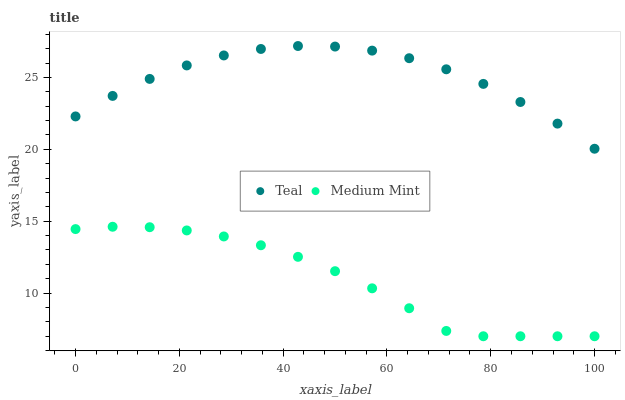Does Medium Mint have the minimum area under the curve?
Answer yes or no. Yes. Does Teal have the maximum area under the curve?
Answer yes or no. Yes. Does Teal have the minimum area under the curve?
Answer yes or no. No. Is Teal the smoothest?
Answer yes or no. Yes. Is Medium Mint the roughest?
Answer yes or no. Yes. Is Teal the roughest?
Answer yes or no. No. Does Medium Mint have the lowest value?
Answer yes or no. Yes. Does Teal have the lowest value?
Answer yes or no. No. Does Teal have the highest value?
Answer yes or no. Yes. Is Medium Mint less than Teal?
Answer yes or no. Yes. Is Teal greater than Medium Mint?
Answer yes or no. Yes. Does Medium Mint intersect Teal?
Answer yes or no. No. 